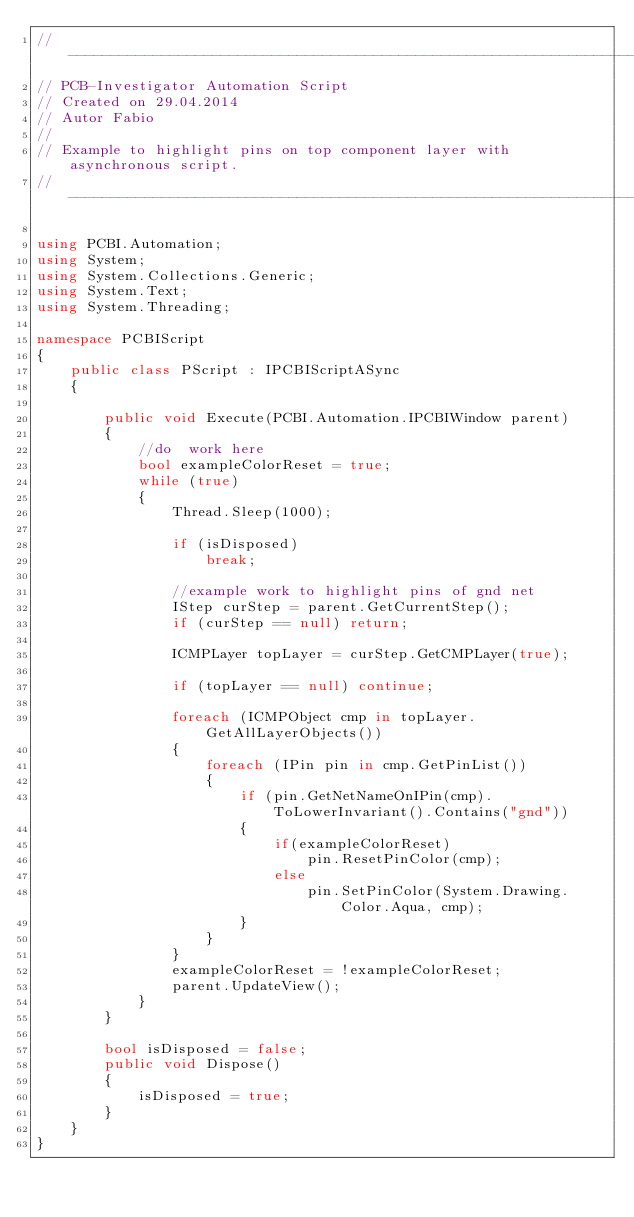Convert code to text. <code><loc_0><loc_0><loc_500><loc_500><_C#_>//-----------------------------------------------------------------------------------
// PCB-Investigator Automation Script
// Created on 29.04.2014
// Autor Fabio
// 
// Example to highlight pins on top component layer with asynchronous script.
//-----------------------------------------------------------------------------------

using PCBI.Automation;
using System;
using System.Collections.Generic;
using System.Text;
using System.Threading;

namespace PCBIScript
{
    public class PScript : IPCBIScriptASync
    {
       
        public void Execute(PCBI.Automation.IPCBIWindow parent)
        {
            //do  work here
            bool exampleColorReset = true;
            while (true)
            {
                Thread.Sleep(1000);

                if (isDisposed)
                    break;

                //example work to highlight pins of gnd net
                IStep curStep = parent.GetCurrentStep();
                if (curStep == null) return;

                ICMPLayer topLayer = curStep.GetCMPLayer(true);

                if (topLayer == null) continue;

                foreach (ICMPObject cmp in topLayer.GetAllLayerObjects())
                {
                    foreach (IPin pin in cmp.GetPinList())
                    {
                        if (pin.GetNetNameOnIPin(cmp).ToLowerInvariant().Contains("gnd"))
                        {
                            if(exampleColorReset)
                                pin.ResetPinColor(cmp);
                            else
                                pin.SetPinColor(System.Drawing.Color.Aqua, cmp);
                        }
                    }
                }
                exampleColorReset = !exampleColorReset;
				parent.UpdateView();
            }
        }

        bool isDisposed = false;
        public void Dispose()
        {
            isDisposed = true;
        }
    }
}
</code> 